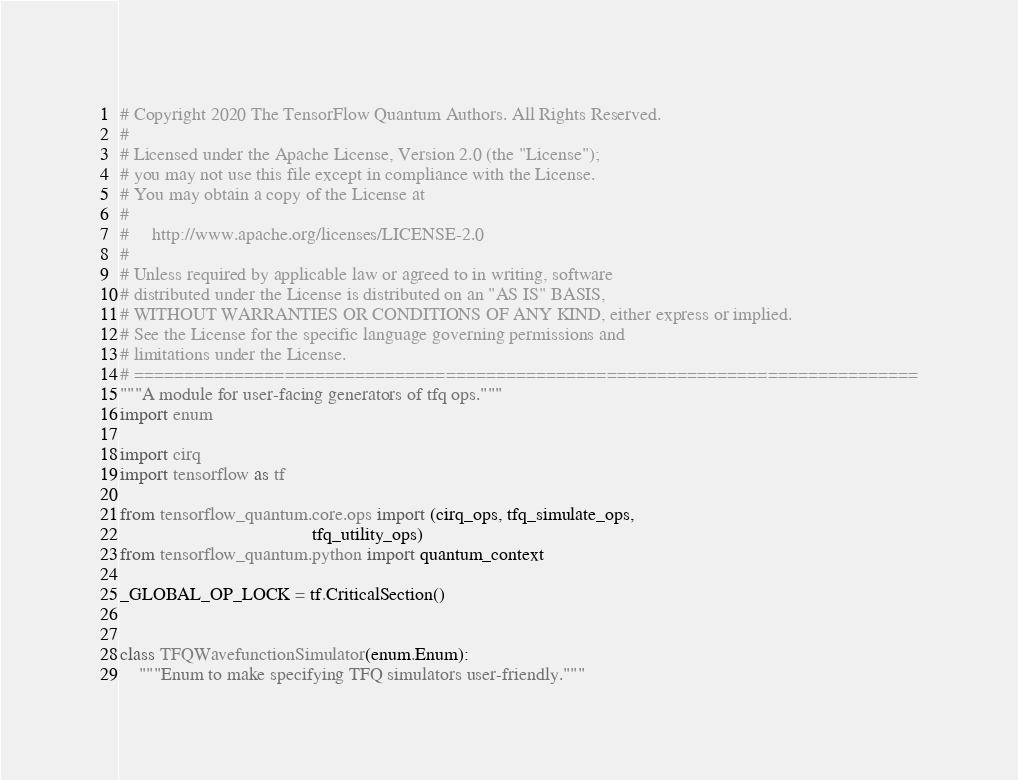Convert code to text. <code><loc_0><loc_0><loc_500><loc_500><_Python_># Copyright 2020 The TensorFlow Quantum Authors. All Rights Reserved.
#
# Licensed under the Apache License, Version 2.0 (the "License");
# you may not use this file except in compliance with the License.
# You may obtain a copy of the License at
#
#     http://www.apache.org/licenses/LICENSE-2.0
#
# Unless required by applicable law or agreed to in writing, software
# distributed under the License is distributed on an "AS IS" BASIS,
# WITHOUT WARRANTIES OR CONDITIONS OF ANY KIND, either express or implied.
# See the License for the specific language governing permissions and
# limitations under the License.
# ==============================================================================
"""A module for user-facing generators of tfq ops."""
import enum

import cirq
import tensorflow as tf

from tensorflow_quantum.core.ops import (cirq_ops, tfq_simulate_ops,
                                         tfq_utility_ops)
from tensorflow_quantum.python import quantum_context

_GLOBAL_OP_LOCK = tf.CriticalSection()


class TFQWavefunctionSimulator(enum.Enum):
    """Enum to make specifying TFQ simulators user-friendly."""</code> 